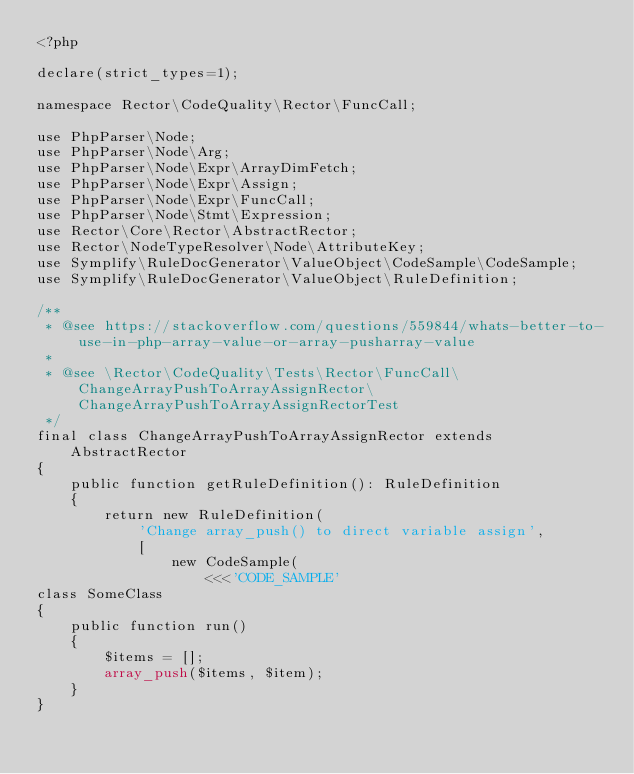Convert code to text. <code><loc_0><loc_0><loc_500><loc_500><_PHP_><?php

declare(strict_types=1);

namespace Rector\CodeQuality\Rector\FuncCall;

use PhpParser\Node;
use PhpParser\Node\Arg;
use PhpParser\Node\Expr\ArrayDimFetch;
use PhpParser\Node\Expr\Assign;
use PhpParser\Node\Expr\FuncCall;
use PhpParser\Node\Stmt\Expression;
use Rector\Core\Rector\AbstractRector;
use Rector\NodeTypeResolver\Node\AttributeKey;
use Symplify\RuleDocGenerator\ValueObject\CodeSample\CodeSample;
use Symplify\RuleDocGenerator\ValueObject\RuleDefinition;

/**
 * @see https://stackoverflow.com/questions/559844/whats-better-to-use-in-php-array-value-or-array-pusharray-value
 *
 * @see \Rector\CodeQuality\Tests\Rector\FuncCall\ChangeArrayPushToArrayAssignRector\ChangeArrayPushToArrayAssignRectorTest
 */
final class ChangeArrayPushToArrayAssignRector extends AbstractRector
{
    public function getRuleDefinition(): RuleDefinition
    {
        return new RuleDefinition(
            'Change array_push() to direct variable assign',
            [
                new CodeSample(
                    <<<'CODE_SAMPLE'
class SomeClass
{
    public function run()
    {
        $items = [];
        array_push($items, $item);
    }
}</code> 